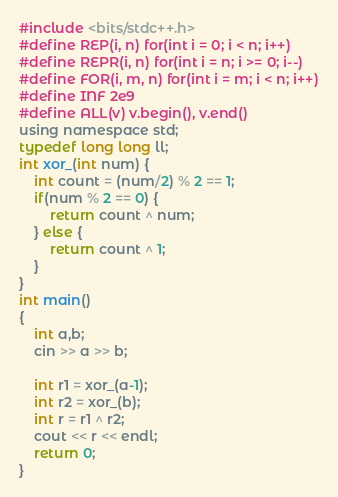Convert code to text. <code><loc_0><loc_0><loc_500><loc_500><_C_>#include <bits/stdc++.h>
#define REP(i, n) for(int i = 0; i < n; i++)
#define REPR(i, n) for(int i = n; i >= 0; i--)
#define FOR(i, m, n) for(int i = m; i < n; i++)
#define INF 2e9
#define ALL(v) v.begin(), v.end()
using namespace std;
typedef long long ll;
int xor_(int num) {
	int count = (num/2) % 2 == 1;
	if(num % 2 == 0) {
		return count ^ num;
	} else {
		return count ^ 1;
	}
}
int main()
{
	int a,b;
	cin >> a >> b;
	
	int r1 = xor_(a-1);
	int r2 = xor_(b);
	int r = r1 ^ r2;
	cout << r << endl;
	return 0;
}</code> 